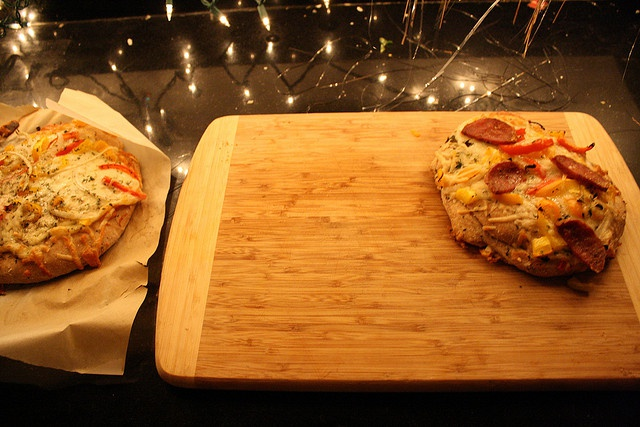Describe the objects in this image and their specific colors. I can see dining table in tan, orange, and red tones, dining table in tan, maroon, black, and brown tones, pizza in tan, brown, red, maroon, and orange tones, pizza in tan, orange, and red tones, and wine glass in tan, black, maroon, and brown tones in this image. 